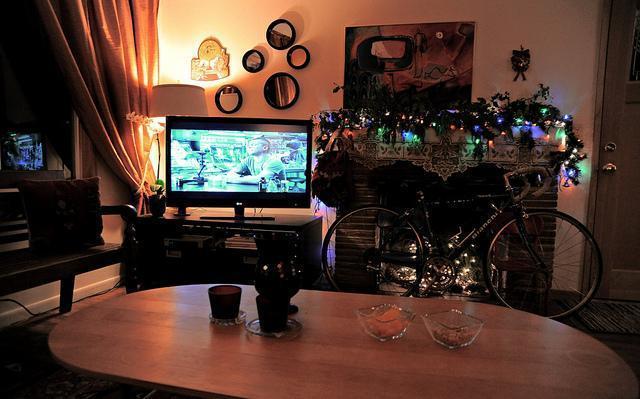How many circle pictures are on the wall?
Give a very brief answer. 5. How many tvs are there?
Give a very brief answer. 2. How many bicycles are in the picture?
Give a very brief answer. 1. How many chairs can be seen?
Give a very brief answer. 1. 